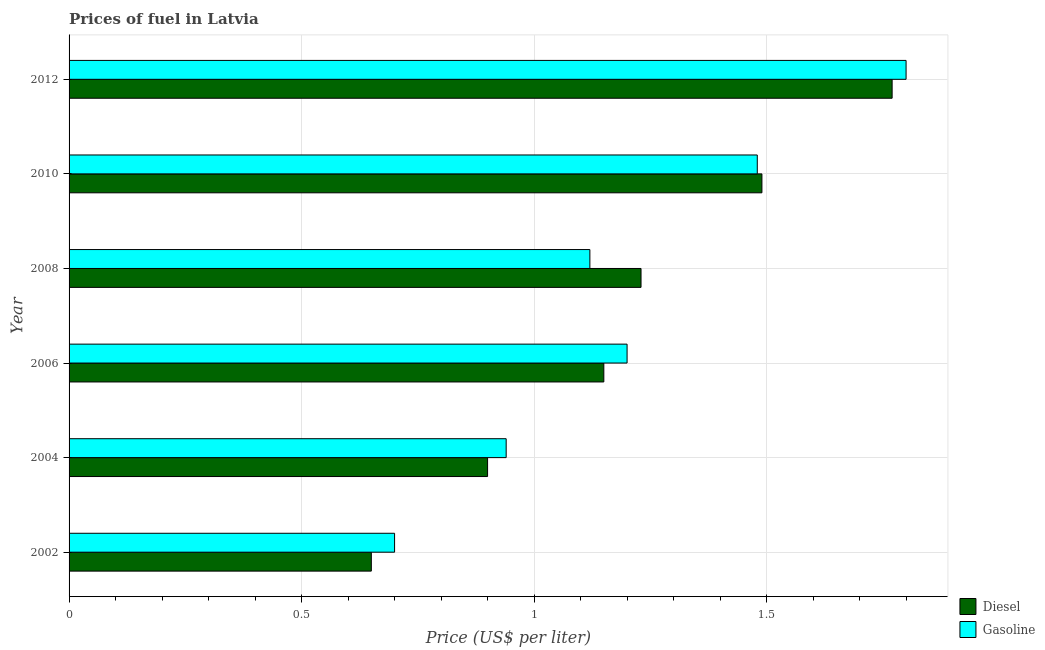Are the number of bars per tick equal to the number of legend labels?
Your answer should be compact. Yes. How many bars are there on the 3rd tick from the bottom?
Offer a very short reply. 2. What is the diesel price in 2006?
Your response must be concise. 1.15. Across all years, what is the maximum diesel price?
Make the answer very short. 1.77. Across all years, what is the minimum diesel price?
Make the answer very short. 0.65. In which year was the diesel price minimum?
Your answer should be compact. 2002. What is the total gasoline price in the graph?
Your answer should be compact. 7.24. What is the difference between the diesel price in 2004 and that in 2012?
Give a very brief answer. -0.87. What is the difference between the gasoline price in 2006 and the diesel price in 2012?
Provide a succinct answer. -0.57. What is the average diesel price per year?
Ensure brevity in your answer.  1.2. In the year 2008, what is the difference between the diesel price and gasoline price?
Provide a succinct answer. 0.11. What is the ratio of the gasoline price in 2006 to that in 2008?
Provide a succinct answer. 1.07. What is the difference between the highest and the second highest diesel price?
Keep it short and to the point. 0.28. What is the difference between the highest and the lowest gasoline price?
Offer a very short reply. 1.1. In how many years, is the diesel price greater than the average diesel price taken over all years?
Your answer should be very brief. 3. Is the sum of the gasoline price in 2002 and 2008 greater than the maximum diesel price across all years?
Provide a succinct answer. Yes. What does the 1st bar from the top in 2004 represents?
Your answer should be compact. Gasoline. What does the 2nd bar from the bottom in 2002 represents?
Your answer should be very brief. Gasoline. How many bars are there?
Ensure brevity in your answer.  12. Where does the legend appear in the graph?
Make the answer very short. Bottom right. How many legend labels are there?
Your answer should be very brief. 2. What is the title of the graph?
Offer a very short reply. Prices of fuel in Latvia. What is the label or title of the X-axis?
Give a very brief answer. Price (US$ per liter). What is the Price (US$ per liter) of Diesel in 2002?
Your answer should be very brief. 0.65. What is the Price (US$ per liter) of Gasoline in 2002?
Provide a short and direct response. 0.7. What is the Price (US$ per liter) of Diesel in 2004?
Make the answer very short. 0.9. What is the Price (US$ per liter) of Gasoline in 2004?
Offer a terse response. 0.94. What is the Price (US$ per liter) of Diesel in 2006?
Make the answer very short. 1.15. What is the Price (US$ per liter) of Diesel in 2008?
Make the answer very short. 1.23. What is the Price (US$ per liter) in Gasoline in 2008?
Your answer should be very brief. 1.12. What is the Price (US$ per liter) of Diesel in 2010?
Ensure brevity in your answer.  1.49. What is the Price (US$ per liter) in Gasoline in 2010?
Your answer should be compact. 1.48. What is the Price (US$ per liter) of Diesel in 2012?
Your answer should be compact. 1.77. Across all years, what is the maximum Price (US$ per liter) in Diesel?
Offer a terse response. 1.77. Across all years, what is the minimum Price (US$ per liter) of Diesel?
Make the answer very short. 0.65. Across all years, what is the minimum Price (US$ per liter) in Gasoline?
Make the answer very short. 0.7. What is the total Price (US$ per liter) in Diesel in the graph?
Your answer should be compact. 7.19. What is the total Price (US$ per liter) in Gasoline in the graph?
Offer a terse response. 7.24. What is the difference between the Price (US$ per liter) in Gasoline in 2002 and that in 2004?
Give a very brief answer. -0.24. What is the difference between the Price (US$ per liter) in Diesel in 2002 and that in 2006?
Provide a succinct answer. -0.5. What is the difference between the Price (US$ per liter) in Gasoline in 2002 and that in 2006?
Ensure brevity in your answer.  -0.5. What is the difference between the Price (US$ per liter) of Diesel in 2002 and that in 2008?
Give a very brief answer. -0.58. What is the difference between the Price (US$ per liter) of Gasoline in 2002 and that in 2008?
Provide a succinct answer. -0.42. What is the difference between the Price (US$ per liter) of Diesel in 2002 and that in 2010?
Offer a very short reply. -0.84. What is the difference between the Price (US$ per liter) of Gasoline in 2002 and that in 2010?
Offer a very short reply. -0.78. What is the difference between the Price (US$ per liter) in Diesel in 2002 and that in 2012?
Ensure brevity in your answer.  -1.12. What is the difference between the Price (US$ per liter) in Gasoline in 2002 and that in 2012?
Your answer should be very brief. -1.1. What is the difference between the Price (US$ per liter) in Gasoline in 2004 and that in 2006?
Provide a short and direct response. -0.26. What is the difference between the Price (US$ per liter) in Diesel in 2004 and that in 2008?
Offer a terse response. -0.33. What is the difference between the Price (US$ per liter) of Gasoline in 2004 and that in 2008?
Your answer should be very brief. -0.18. What is the difference between the Price (US$ per liter) in Diesel in 2004 and that in 2010?
Give a very brief answer. -0.59. What is the difference between the Price (US$ per liter) in Gasoline in 2004 and that in 2010?
Your answer should be very brief. -0.54. What is the difference between the Price (US$ per liter) of Diesel in 2004 and that in 2012?
Give a very brief answer. -0.87. What is the difference between the Price (US$ per liter) in Gasoline in 2004 and that in 2012?
Provide a short and direct response. -0.86. What is the difference between the Price (US$ per liter) of Diesel in 2006 and that in 2008?
Ensure brevity in your answer.  -0.08. What is the difference between the Price (US$ per liter) of Diesel in 2006 and that in 2010?
Keep it short and to the point. -0.34. What is the difference between the Price (US$ per liter) in Gasoline in 2006 and that in 2010?
Your answer should be compact. -0.28. What is the difference between the Price (US$ per liter) of Diesel in 2006 and that in 2012?
Your response must be concise. -0.62. What is the difference between the Price (US$ per liter) of Gasoline in 2006 and that in 2012?
Ensure brevity in your answer.  -0.6. What is the difference between the Price (US$ per liter) of Diesel in 2008 and that in 2010?
Your answer should be very brief. -0.26. What is the difference between the Price (US$ per liter) in Gasoline in 2008 and that in 2010?
Your answer should be very brief. -0.36. What is the difference between the Price (US$ per liter) in Diesel in 2008 and that in 2012?
Offer a very short reply. -0.54. What is the difference between the Price (US$ per liter) in Gasoline in 2008 and that in 2012?
Keep it short and to the point. -0.68. What is the difference between the Price (US$ per liter) in Diesel in 2010 and that in 2012?
Your answer should be compact. -0.28. What is the difference between the Price (US$ per liter) in Gasoline in 2010 and that in 2012?
Keep it short and to the point. -0.32. What is the difference between the Price (US$ per liter) of Diesel in 2002 and the Price (US$ per liter) of Gasoline in 2004?
Offer a very short reply. -0.29. What is the difference between the Price (US$ per liter) in Diesel in 2002 and the Price (US$ per liter) in Gasoline in 2006?
Offer a very short reply. -0.55. What is the difference between the Price (US$ per liter) in Diesel in 2002 and the Price (US$ per liter) in Gasoline in 2008?
Offer a terse response. -0.47. What is the difference between the Price (US$ per liter) in Diesel in 2002 and the Price (US$ per liter) in Gasoline in 2010?
Your response must be concise. -0.83. What is the difference between the Price (US$ per liter) in Diesel in 2002 and the Price (US$ per liter) in Gasoline in 2012?
Your answer should be compact. -1.15. What is the difference between the Price (US$ per liter) of Diesel in 2004 and the Price (US$ per liter) of Gasoline in 2008?
Your answer should be very brief. -0.22. What is the difference between the Price (US$ per liter) in Diesel in 2004 and the Price (US$ per liter) in Gasoline in 2010?
Keep it short and to the point. -0.58. What is the difference between the Price (US$ per liter) in Diesel in 2004 and the Price (US$ per liter) in Gasoline in 2012?
Your response must be concise. -0.9. What is the difference between the Price (US$ per liter) in Diesel in 2006 and the Price (US$ per liter) in Gasoline in 2008?
Your response must be concise. 0.03. What is the difference between the Price (US$ per liter) of Diesel in 2006 and the Price (US$ per liter) of Gasoline in 2010?
Provide a short and direct response. -0.33. What is the difference between the Price (US$ per liter) of Diesel in 2006 and the Price (US$ per liter) of Gasoline in 2012?
Provide a succinct answer. -0.65. What is the difference between the Price (US$ per liter) of Diesel in 2008 and the Price (US$ per liter) of Gasoline in 2010?
Make the answer very short. -0.25. What is the difference between the Price (US$ per liter) of Diesel in 2008 and the Price (US$ per liter) of Gasoline in 2012?
Offer a very short reply. -0.57. What is the difference between the Price (US$ per liter) in Diesel in 2010 and the Price (US$ per liter) in Gasoline in 2012?
Give a very brief answer. -0.31. What is the average Price (US$ per liter) in Diesel per year?
Ensure brevity in your answer.  1.2. What is the average Price (US$ per liter) of Gasoline per year?
Give a very brief answer. 1.21. In the year 2004, what is the difference between the Price (US$ per liter) of Diesel and Price (US$ per liter) of Gasoline?
Give a very brief answer. -0.04. In the year 2006, what is the difference between the Price (US$ per liter) in Diesel and Price (US$ per liter) in Gasoline?
Your answer should be very brief. -0.05. In the year 2008, what is the difference between the Price (US$ per liter) in Diesel and Price (US$ per liter) in Gasoline?
Give a very brief answer. 0.11. In the year 2010, what is the difference between the Price (US$ per liter) in Diesel and Price (US$ per liter) in Gasoline?
Give a very brief answer. 0.01. In the year 2012, what is the difference between the Price (US$ per liter) in Diesel and Price (US$ per liter) in Gasoline?
Keep it short and to the point. -0.03. What is the ratio of the Price (US$ per liter) of Diesel in 2002 to that in 2004?
Offer a terse response. 0.72. What is the ratio of the Price (US$ per liter) in Gasoline in 2002 to that in 2004?
Your answer should be very brief. 0.74. What is the ratio of the Price (US$ per liter) of Diesel in 2002 to that in 2006?
Offer a terse response. 0.57. What is the ratio of the Price (US$ per liter) in Gasoline in 2002 to that in 2006?
Your answer should be compact. 0.58. What is the ratio of the Price (US$ per liter) in Diesel in 2002 to that in 2008?
Keep it short and to the point. 0.53. What is the ratio of the Price (US$ per liter) of Diesel in 2002 to that in 2010?
Ensure brevity in your answer.  0.44. What is the ratio of the Price (US$ per liter) in Gasoline in 2002 to that in 2010?
Offer a terse response. 0.47. What is the ratio of the Price (US$ per liter) of Diesel in 2002 to that in 2012?
Your answer should be compact. 0.37. What is the ratio of the Price (US$ per liter) in Gasoline in 2002 to that in 2012?
Your response must be concise. 0.39. What is the ratio of the Price (US$ per liter) of Diesel in 2004 to that in 2006?
Give a very brief answer. 0.78. What is the ratio of the Price (US$ per liter) in Gasoline in 2004 to that in 2006?
Make the answer very short. 0.78. What is the ratio of the Price (US$ per liter) in Diesel in 2004 to that in 2008?
Your response must be concise. 0.73. What is the ratio of the Price (US$ per liter) of Gasoline in 2004 to that in 2008?
Ensure brevity in your answer.  0.84. What is the ratio of the Price (US$ per liter) of Diesel in 2004 to that in 2010?
Keep it short and to the point. 0.6. What is the ratio of the Price (US$ per liter) in Gasoline in 2004 to that in 2010?
Provide a succinct answer. 0.64. What is the ratio of the Price (US$ per liter) of Diesel in 2004 to that in 2012?
Give a very brief answer. 0.51. What is the ratio of the Price (US$ per liter) in Gasoline in 2004 to that in 2012?
Keep it short and to the point. 0.52. What is the ratio of the Price (US$ per liter) in Diesel in 2006 to that in 2008?
Keep it short and to the point. 0.94. What is the ratio of the Price (US$ per liter) in Gasoline in 2006 to that in 2008?
Your answer should be compact. 1.07. What is the ratio of the Price (US$ per liter) in Diesel in 2006 to that in 2010?
Your answer should be very brief. 0.77. What is the ratio of the Price (US$ per liter) in Gasoline in 2006 to that in 2010?
Keep it short and to the point. 0.81. What is the ratio of the Price (US$ per liter) in Diesel in 2006 to that in 2012?
Give a very brief answer. 0.65. What is the ratio of the Price (US$ per liter) of Diesel in 2008 to that in 2010?
Offer a terse response. 0.83. What is the ratio of the Price (US$ per liter) in Gasoline in 2008 to that in 2010?
Your answer should be compact. 0.76. What is the ratio of the Price (US$ per liter) of Diesel in 2008 to that in 2012?
Make the answer very short. 0.69. What is the ratio of the Price (US$ per liter) of Gasoline in 2008 to that in 2012?
Your answer should be compact. 0.62. What is the ratio of the Price (US$ per liter) in Diesel in 2010 to that in 2012?
Ensure brevity in your answer.  0.84. What is the ratio of the Price (US$ per liter) in Gasoline in 2010 to that in 2012?
Provide a short and direct response. 0.82. What is the difference between the highest and the second highest Price (US$ per liter) in Diesel?
Offer a very short reply. 0.28. What is the difference between the highest and the second highest Price (US$ per liter) of Gasoline?
Your response must be concise. 0.32. What is the difference between the highest and the lowest Price (US$ per liter) in Diesel?
Your answer should be very brief. 1.12. 